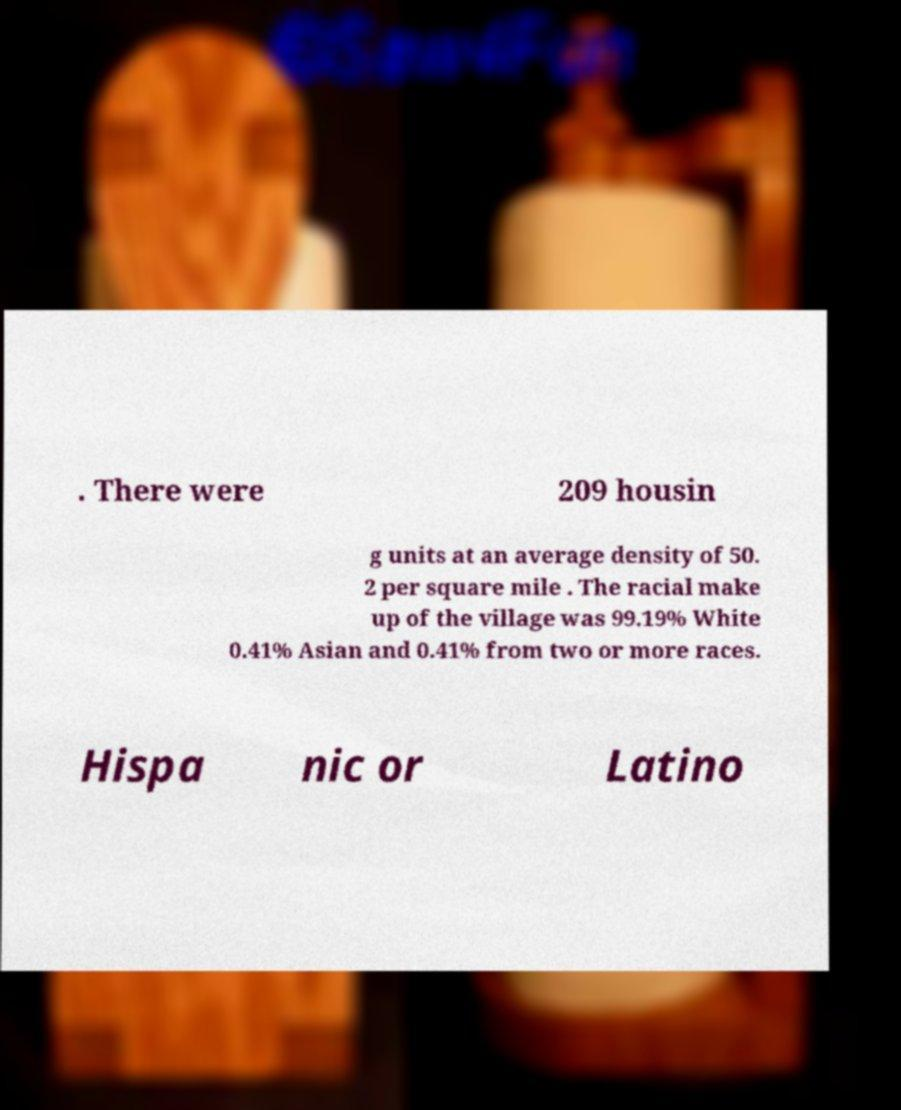What messages or text are displayed in this image? I need them in a readable, typed format. . There were 209 housin g units at an average density of 50. 2 per square mile . The racial make up of the village was 99.19% White 0.41% Asian and 0.41% from two or more races. Hispa nic or Latino 